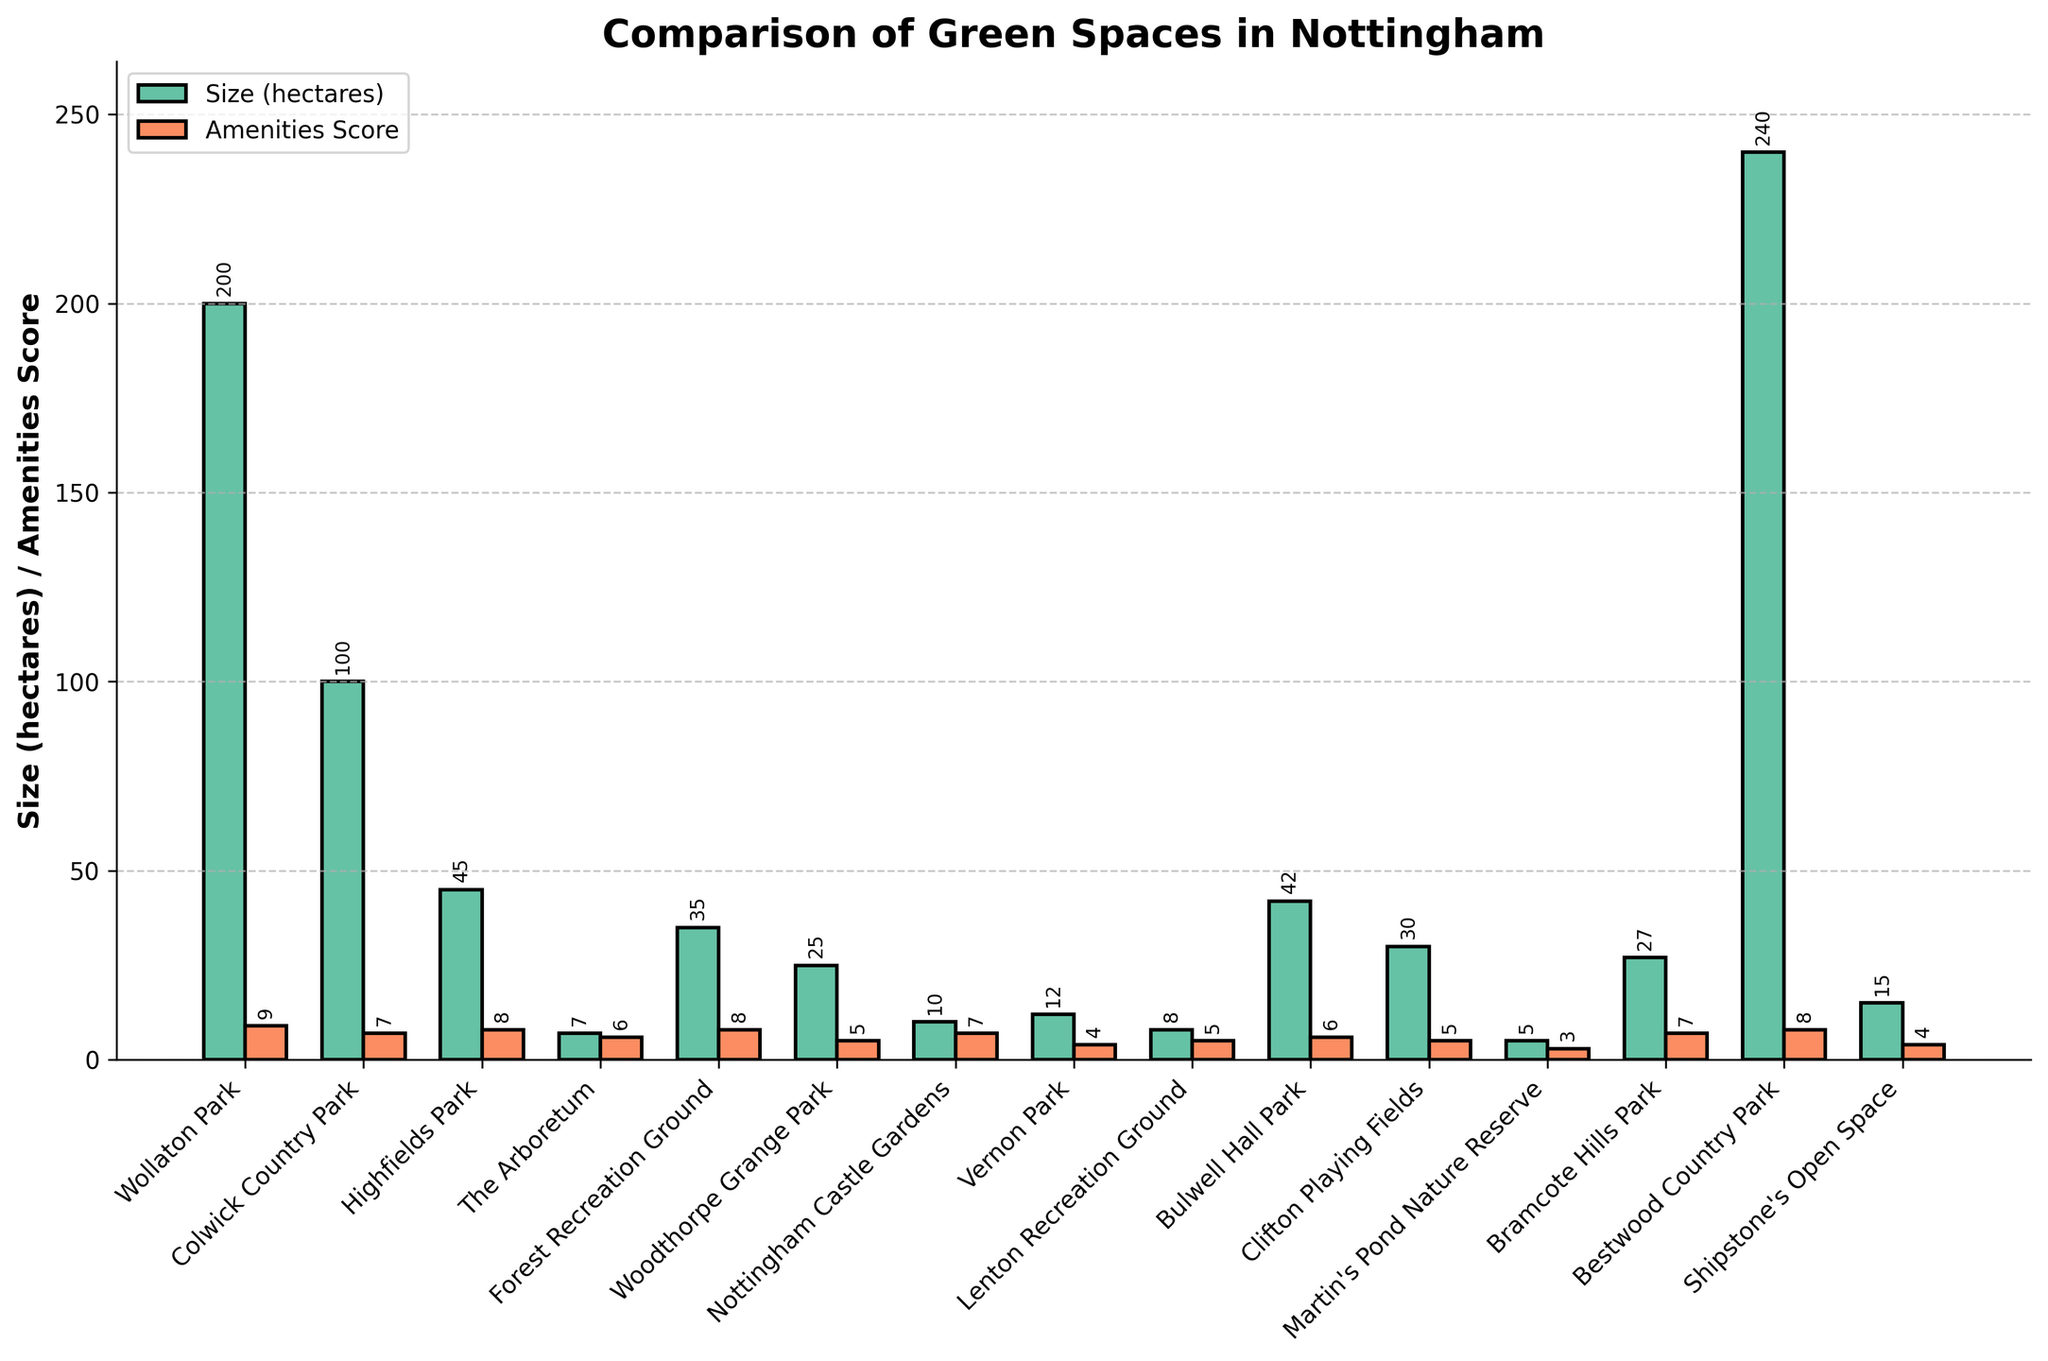What is the largest green space in Nottingham in terms of size? The figure shows the sizes of each green space as bars. The bar representing Bestwood Country Park is the tallest, indicating it is the largest green space.
Answer: Bestwood Country Park How does the size of Wollaton Park compare to that of Colwick Country Park? Visually compare the heights of the bars for Wollaton Park and Colwick Country Park. The bar for Wollaton Park is higher, indicating it is larger than Colwick Country Park.
Answer: Wollaton Park is larger Which park has the highest amenities score? Look at the bars labeled "Amenities Score" in the orange color. The tallest bar indicates the highest amenities score. It corresponds to Wollaton Park.
Answer: Wollaton Park What is the combined size of Highfields Park and Bulwell Hall Park? Add the sizes (hectares) of Highfields Park and Bulwell Hall Park. From the figure, these are 45 and 42 respectively. 45 + 42 = 87 hectares.
Answer: 87 hectares Is there any park with both high size (over 100 hectares) and high amenities score (8 or above)? Look for bars that exceed 100 hectares in size and have corresponding high amenities scores. Bestwood Country Park (240 hectares, amenities score 8) fits both criteria.
Answer: Bestwood Country Park What is the difference in amenities scores between Forest Recreation Ground and Woodthorpe Grange Park? Find the amenities scores for both parks: Forest Recreation Ground is 8 and Woodthorpe Grange Park is 5. The difference is 8 - 5 = 3.
Answer: 3 Which park has a size just above 40 hectares? Check the heights of the bars around the 40-hectare mark. Bulwell Hall Park has a size of 42 hectares which is just above 40 hectares.
Answer: Bulwell Hall Park Which park has the smallest size, and what is its amenities score? Identify the shortest bar in the "Size (hectares)" category. Martin's Pond Nature Reserve has the smallest size at 5 hectares and its amenities score is 3.
Answer: Martin's Pond Nature Reserve, score 3 What is the total amenities score for all parks combined? Sum the amenities scores of all parks. The scores are: 9, 7, 8, 6, 8, 5, 7, 4, 5, 6, 5, 3, 7, 8, and 4. The total is 9 + 7 + 8 + 6 + 8 + 5 + 7 + 4 + 5 + 6 + 5 + 3 + 7 + 8 + 4 = 92.
Answer: 92 Are there more parks with a size greater than 30 hectares or an amenities score of 7 or higher? Count the parks with sizes greater than 30 hectares, then count those with amenities scores of 7 or higher. Sizes greater than 30 include Wollaton Park, Colwick Country Park, Highfields Park, Forest Recreation Ground, Bulwell Hall Park, Clifton Playing Fields, and Bestwood Country Park (7 parks). Amenities scores of 7 or higher include Wollaton Park, Colwick Country Park, Highfields Park, The Arboretum, Nottingham Castle Gardens, Lenton Recreation Ground, Bramcote Hills Park, and Bestwood Country Park (8 parks).
Answer: Amenities score of 7 or higher 